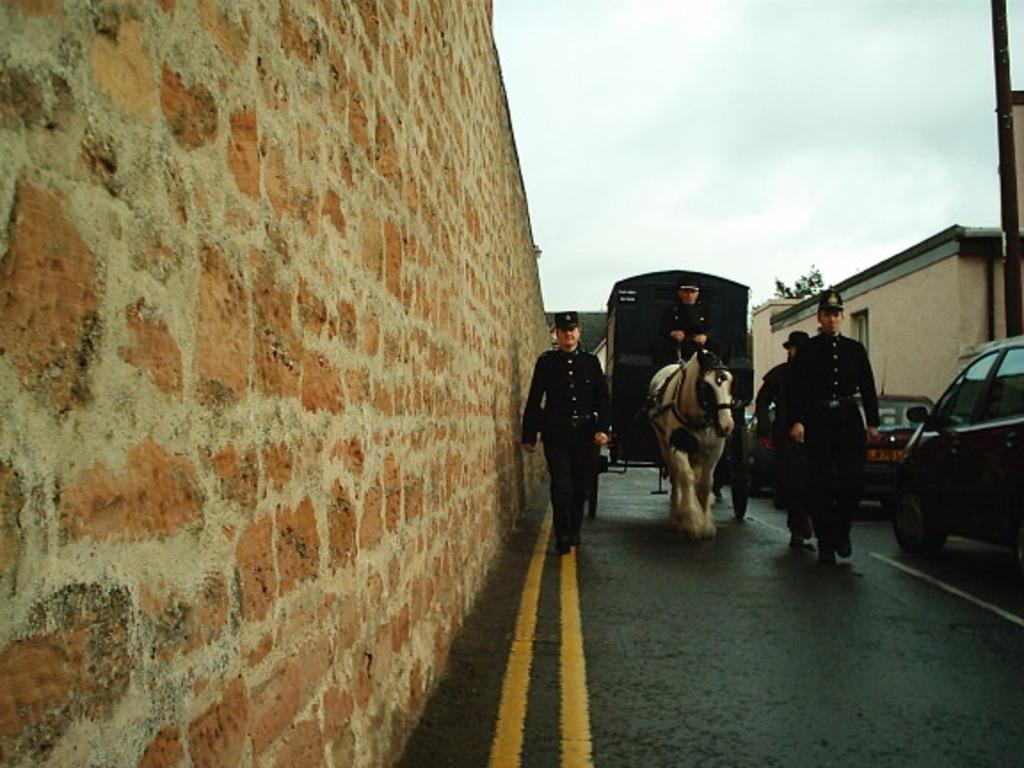Can you describe this image briefly? In this Image I see a person who is in the cart and riding horse and I see another 3 persons who are on the path and I see vehicles and a house over here and I can also see a wall. 